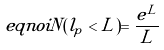<formula> <loc_0><loc_0><loc_500><loc_500>\ e q n o i N ( l _ { p } < L ) = \frac { e ^ { L } } { L }</formula> 